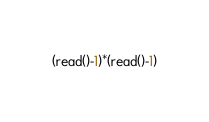<code> <loc_0><loc_0><loc_500><loc_500><_bc_>(read()-1)*(read()-1)</code> 